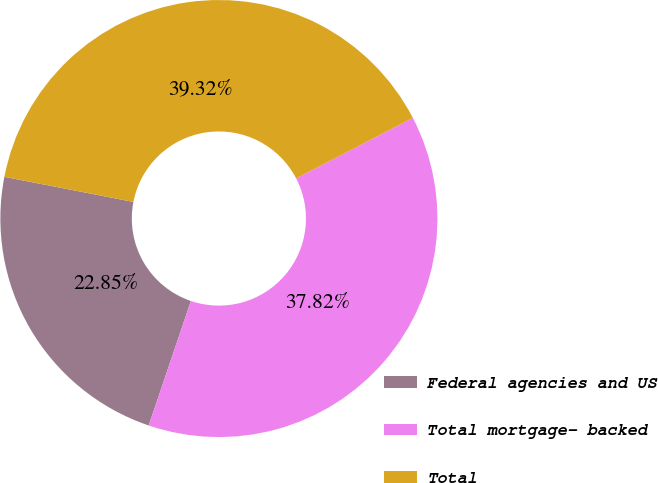Convert chart to OTSL. <chart><loc_0><loc_0><loc_500><loc_500><pie_chart><fcel>Federal agencies and US<fcel>Total mortgage- backed<fcel>Total<nl><fcel>22.85%<fcel>37.82%<fcel>39.32%<nl></chart> 